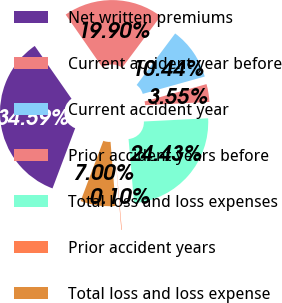Convert chart. <chart><loc_0><loc_0><loc_500><loc_500><pie_chart><fcel>Net written premiums<fcel>Current accident year before<fcel>Current accident year<fcel>Prior accident years before<fcel>Total loss and loss expenses<fcel>Prior accident years<fcel>Total loss and loss expense<nl><fcel>34.59%<fcel>19.9%<fcel>10.44%<fcel>3.55%<fcel>24.43%<fcel>0.1%<fcel>7.0%<nl></chart> 